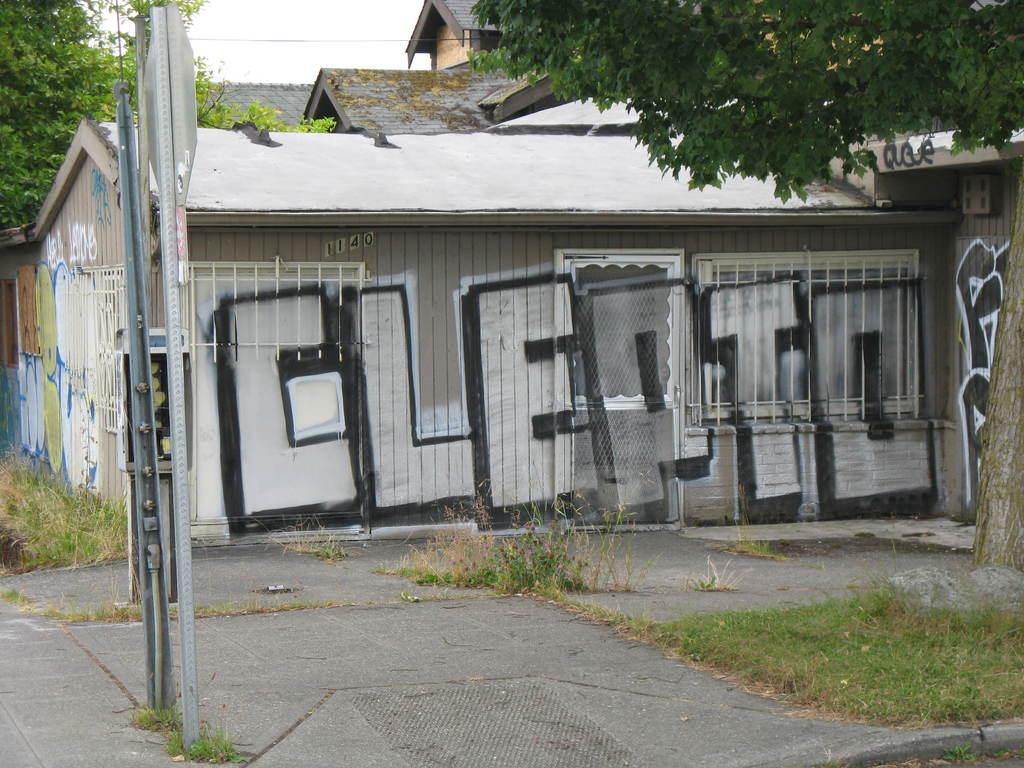What type of structures can be seen in the image? There are buildings in the image. What natural elements are present in the image? There are trees and grass in the image. What man-made objects can be seen in the image? Metal poles are visible in the image. What can be seen in the background of the image? The sky is visible in the background of the image. Can you see a toad helping someone comb their hair in the image? No, there is no toad or anyone combing their hair in the image. 